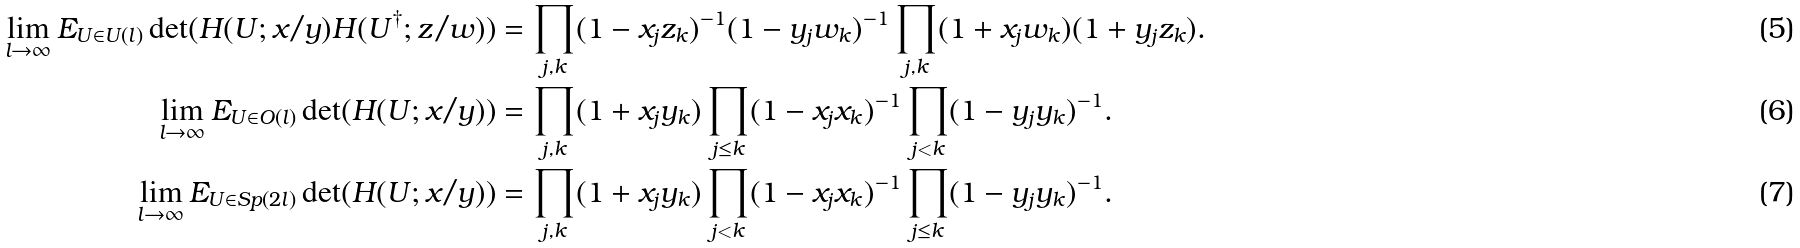Convert formula to latex. <formula><loc_0><loc_0><loc_500><loc_500>\lim _ { l \to \infty } E _ { U \in U ( l ) } \det ( H ( U ; x / y ) H ( U ^ { \dagger } ; z / w ) ) & = \prod _ { j , k } ( 1 - x _ { j } z _ { k } ) ^ { - 1 } ( 1 - y _ { j } w _ { k } ) ^ { - 1 } \prod _ { j , k } ( 1 + x _ { j } w _ { k } ) ( 1 + y _ { j } z _ { k } ) . \\ \lim _ { l \to \infty } E _ { U \in O ( l ) } \det ( H ( U ; x / y ) ) & = \prod _ { j , k } ( 1 + x _ { j } y _ { k } ) \prod _ { j \leq k } ( 1 - x _ { j } x _ { k } ) ^ { - 1 } \prod _ { j < k } ( 1 - y _ { j } y _ { k } ) ^ { - 1 } . \\ \lim _ { l \to \infty } E _ { U \in S p ( 2 l ) } \det ( H ( U ; x / y ) ) & = \prod _ { j , k } ( 1 + x _ { j } y _ { k } ) \prod _ { j < k } ( 1 - x _ { j } x _ { k } ) ^ { - 1 } \prod _ { j \leq k } ( 1 - y _ { j } y _ { k } ) ^ { - 1 } .</formula> 